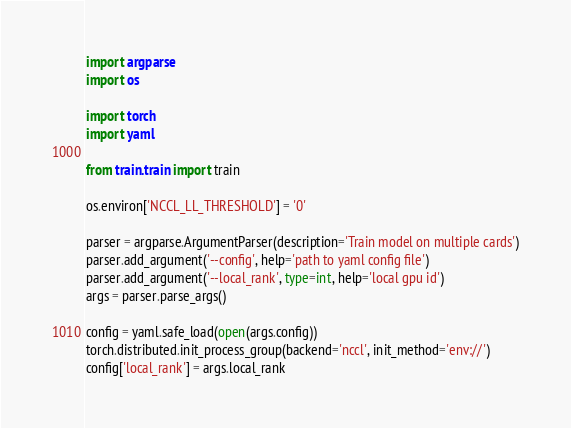Convert code to text. <code><loc_0><loc_0><loc_500><loc_500><_Python_>import argparse
import os

import torch
import yaml

from train.train import train

os.environ['NCCL_LL_THRESHOLD'] = '0'

parser = argparse.ArgumentParser(description='Train model on multiple cards')
parser.add_argument('--config', help='path to yaml config file')
parser.add_argument('--local_rank', type=int, help='local gpu id')
args = parser.parse_args()

config = yaml.safe_load(open(args.config))
torch.distributed.init_process_group(backend='nccl', init_method='env://')
config['local_rank'] = args.local_rank</code> 